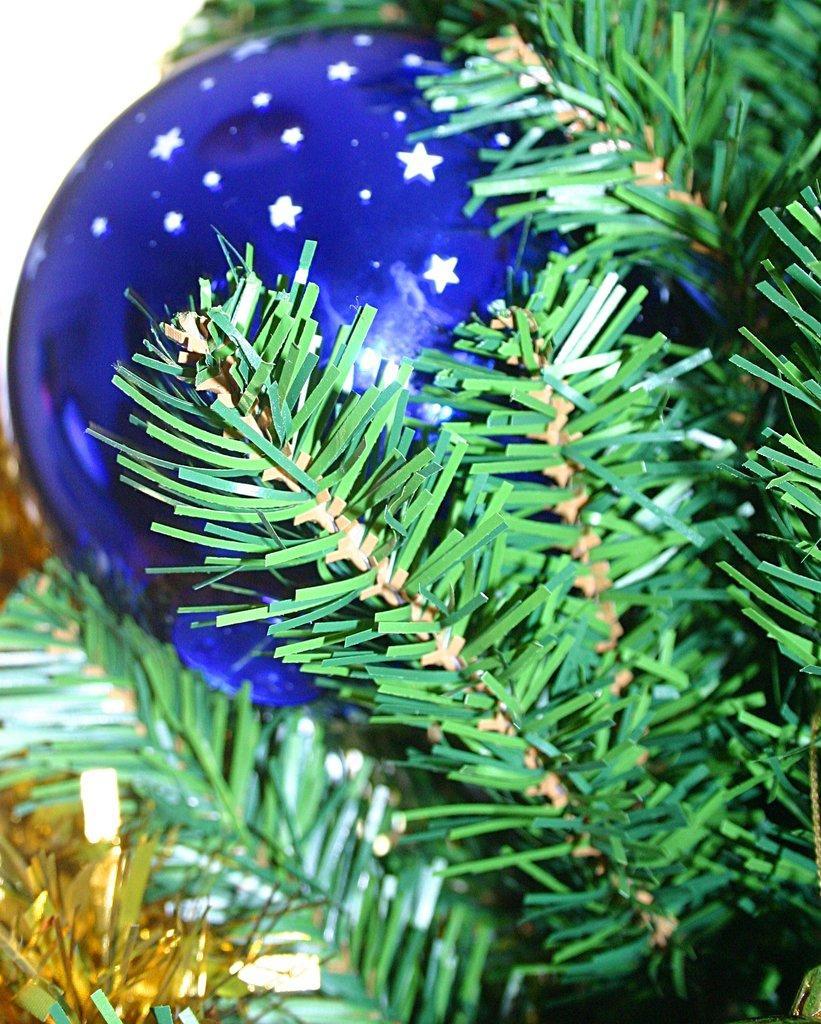Could you give a brief overview of what you see in this image? In this picture we can see a blue Christmas toy ball and a plant. 